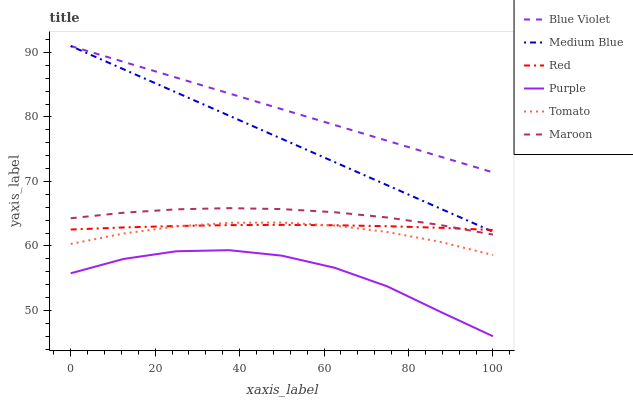Does Purple have the minimum area under the curve?
Answer yes or no. Yes. Does Blue Violet have the maximum area under the curve?
Answer yes or no. Yes. Does Medium Blue have the minimum area under the curve?
Answer yes or no. No. Does Medium Blue have the maximum area under the curve?
Answer yes or no. No. Is Medium Blue the smoothest?
Answer yes or no. Yes. Is Purple the roughest?
Answer yes or no. Yes. Is Purple the smoothest?
Answer yes or no. No. Is Medium Blue the roughest?
Answer yes or no. No. Does Purple have the lowest value?
Answer yes or no. Yes. Does Medium Blue have the lowest value?
Answer yes or no. No. Does Blue Violet have the highest value?
Answer yes or no. Yes. Does Purple have the highest value?
Answer yes or no. No. Is Purple less than Blue Violet?
Answer yes or no. Yes. Is Red greater than Purple?
Answer yes or no. Yes. Does Medium Blue intersect Blue Violet?
Answer yes or no. Yes. Is Medium Blue less than Blue Violet?
Answer yes or no. No. Is Medium Blue greater than Blue Violet?
Answer yes or no. No. Does Purple intersect Blue Violet?
Answer yes or no. No. 